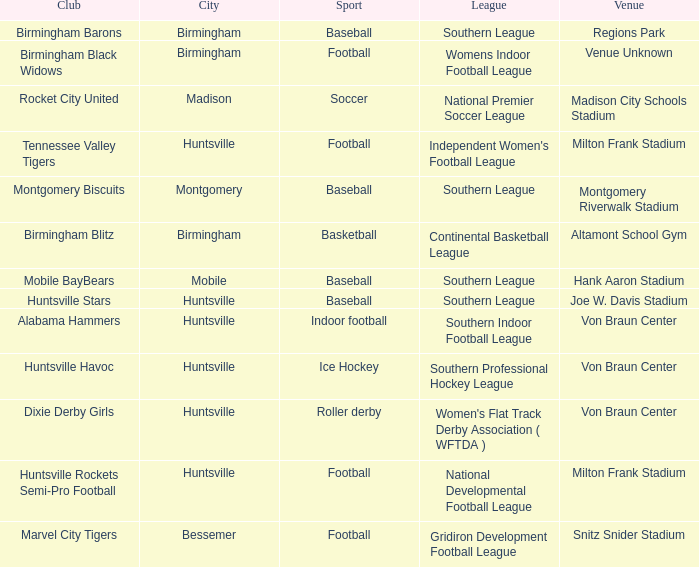Which sport was held in Huntsville at the Von Braun Center as part of the Southern Indoor Football League? Indoor football. 